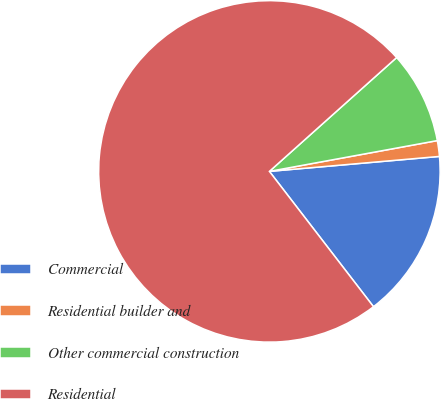Convert chart. <chart><loc_0><loc_0><loc_500><loc_500><pie_chart><fcel>Commercial<fcel>Residential builder and<fcel>Other commercial construction<fcel>Residential<nl><fcel>15.96%<fcel>1.49%<fcel>8.73%<fcel>73.82%<nl></chart> 